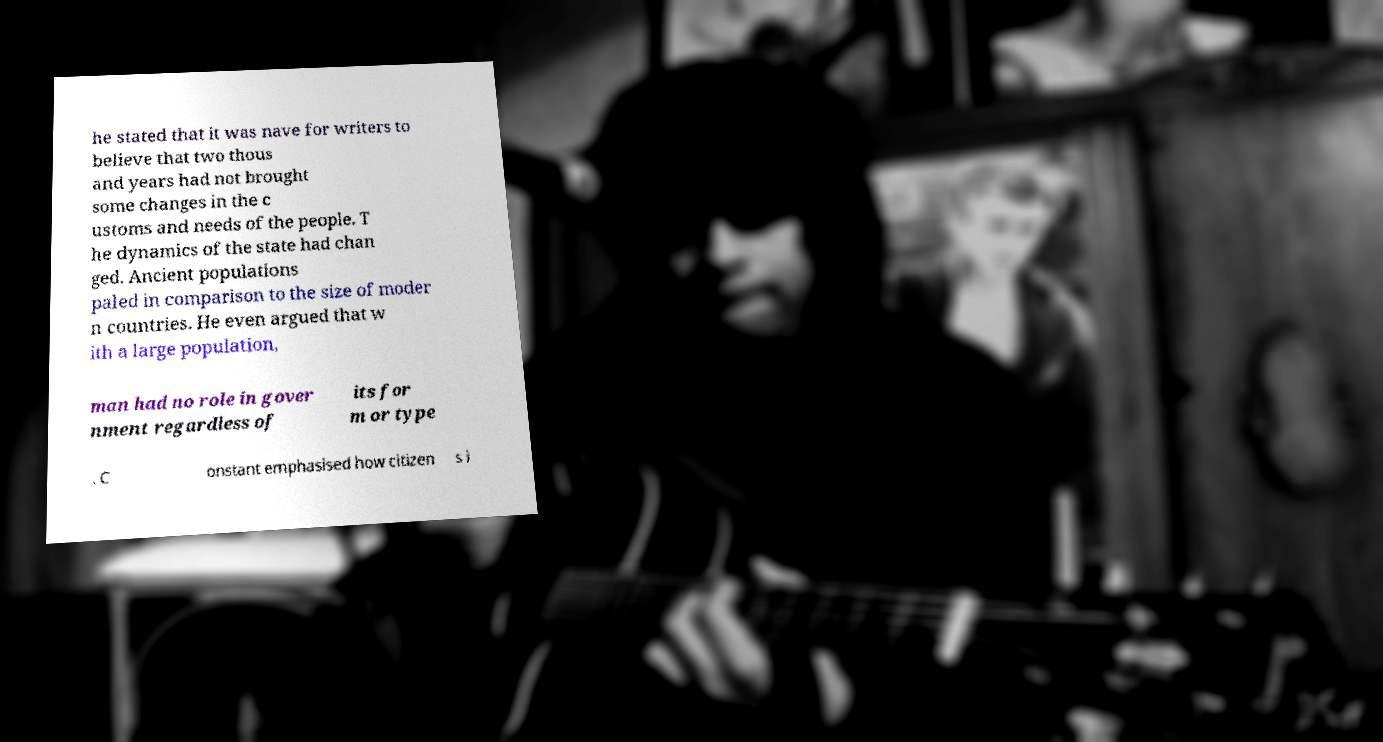For documentation purposes, I need the text within this image transcribed. Could you provide that? he stated that it was nave for writers to believe that two thous and years had not brought some changes in the c ustoms and needs of the people. T he dynamics of the state had chan ged. Ancient populations paled in comparison to the size of moder n countries. He even argued that w ith a large population, man had no role in gover nment regardless of its for m or type . C onstant emphasised how citizen s i 